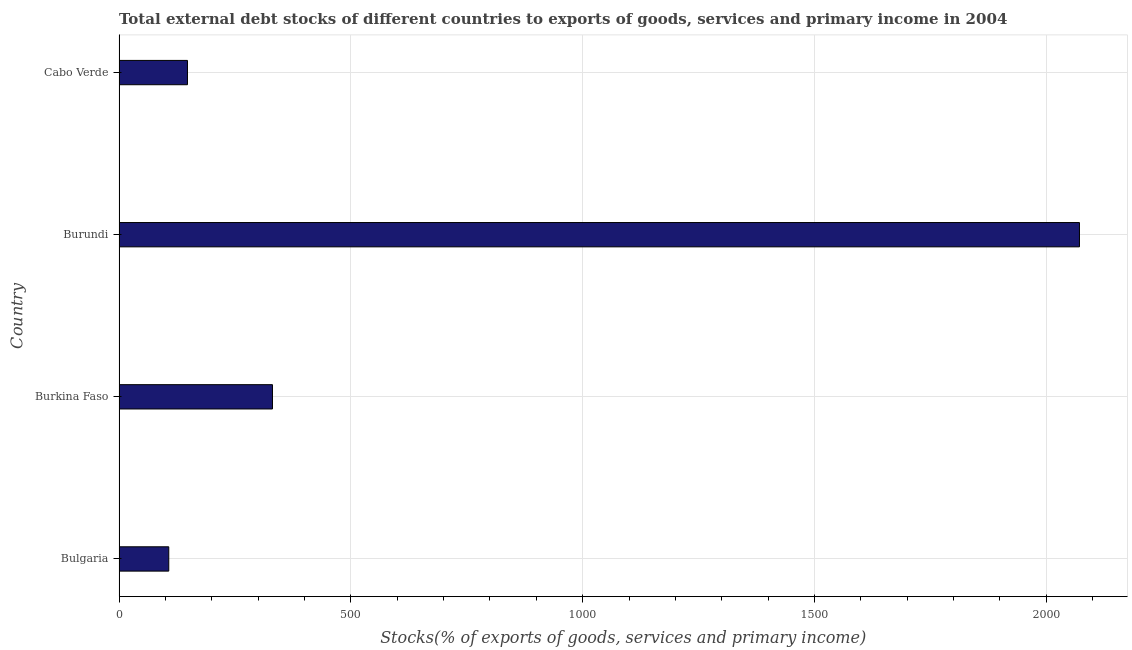Does the graph contain any zero values?
Ensure brevity in your answer.  No. What is the title of the graph?
Your response must be concise. Total external debt stocks of different countries to exports of goods, services and primary income in 2004. What is the label or title of the X-axis?
Your answer should be very brief. Stocks(% of exports of goods, services and primary income). What is the label or title of the Y-axis?
Offer a very short reply. Country. What is the external debt stocks in Burundi?
Make the answer very short. 2071.68. Across all countries, what is the maximum external debt stocks?
Provide a succinct answer. 2071.68. Across all countries, what is the minimum external debt stocks?
Give a very brief answer. 107.23. In which country was the external debt stocks maximum?
Provide a short and direct response. Burundi. What is the sum of the external debt stocks?
Ensure brevity in your answer.  2657.4. What is the difference between the external debt stocks in Burkina Faso and Cabo Verde?
Your answer should be compact. 183.34. What is the average external debt stocks per country?
Make the answer very short. 664.35. What is the median external debt stocks?
Your response must be concise. 239.25. In how many countries, is the external debt stocks greater than 1400 %?
Provide a short and direct response. 1. What is the ratio of the external debt stocks in Bulgaria to that in Burundi?
Your answer should be very brief. 0.05. Is the external debt stocks in Burundi less than that in Cabo Verde?
Provide a succinct answer. No. What is the difference between the highest and the second highest external debt stocks?
Ensure brevity in your answer.  1740.77. Is the sum of the external debt stocks in Burkina Faso and Burundi greater than the maximum external debt stocks across all countries?
Make the answer very short. Yes. What is the difference between the highest and the lowest external debt stocks?
Provide a succinct answer. 1964.45. Are all the bars in the graph horizontal?
Your response must be concise. Yes. Are the values on the major ticks of X-axis written in scientific E-notation?
Give a very brief answer. No. What is the Stocks(% of exports of goods, services and primary income) in Bulgaria?
Your answer should be compact. 107.23. What is the Stocks(% of exports of goods, services and primary income) in Burkina Faso?
Provide a short and direct response. 330.91. What is the Stocks(% of exports of goods, services and primary income) in Burundi?
Give a very brief answer. 2071.68. What is the Stocks(% of exports of goods, services and primary income) in Cabo Verde?
Your answer should be compact. 147.58. What is the difference between the Stocks(% of exports of goods, services and primary income) in Bulgaria and Burkina Faso?
Ensure brevity in your answer.  -223.69. What is the difference between the Stocks(% of exports of goods, services and primary income) in Bulgaria and Burundi?
Ensure brevity in your answer.  -1964.45. What is the difference between the Stocks(% of exports of goods, services and primary income) in Bulgaria and Cabo Verde?
Keep it short and to the point. -40.35. What is the difference between the Stocks(% of exports of goods, services and primary income) in Burkina Faso and Burundi?
Your answer should be very brief. -1740.77. What is the difference between the Stocks(% of exports of goods, services and primary income) in Burkina Faso and Cabo Verde?
Give a very brief answer. 183.34. What is the difference between the Stocks(% of exports of goods, services and primary income) in Burundi and Cabo Verde?
Your answer should be very brief. 1924.11. What is the ratio of the Stocks(% of exports of goods, services and primary income) in Bulgaria to that in Burkina Faso?
Offer a terse response. 0.32. What is the ratio of the Stocks(% of exports of goods, services and primary income) in Bulgaria to that in Burundi?
Provide a succinct answer. 0.05. What is the ratio of the Stocks(% of exports of goods, services and primary income) in Bulgaria to that in Cabo Verde?
Make the answer very short. 0.73. What is the ratio of the Stocks(% of exports of goods, services and primary income) in Burkina Faso to that in Burundi?
Make the answer very short. 0.16. What is the ratio of the Stocks(% of exports of goods, services and primary income) in Burkina Faso to that in Cabo Verde?
Provide a short and direct response. 2.24. What is the ratio of the Stocks(% of exports of goods, services and primary income) in Burundi to that in Cabo Verde?
Your answer should be compact. 14.04. 